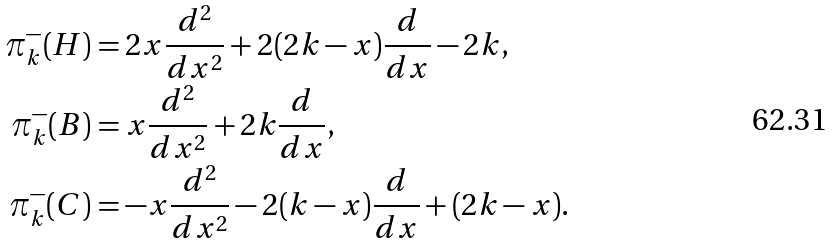Convert formula to latex. <formula><loc_0><loc_0><loc_500><loc_500>\pi ^ { - } _ { k } ( H ) & = 2 x \frac { d ^ { 2 } } { d x ^ { 2 } } + 2 ( 2 k - x ) \frac { d } { d x } - 2 k , \\ \pi ^ { - } _ { k } ( B ) & = x \frac { d ^ { 2 } } { d x ^ { 2 } } + 2 k \frac { d } { d x } , \\ \pi ^ { - } _ { k } ( C ) & = - x \frac { d ^ { 2 } } { d x ^ { 2 } } - 2 ( k - x ) \frac { d } { d x } + ( 2 k - x ) .</formula> 